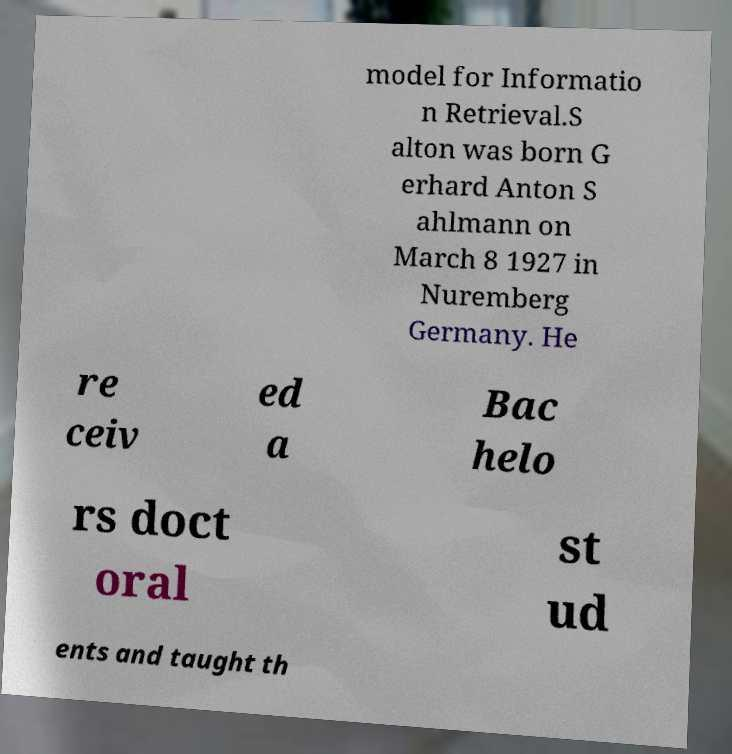There's text embedded in this image that I need extracted. Can you transcribe it verbatim? model for Informatio n Retrieval.S alton was born G erhard Anton S ahlmann on March 8 1927 in Nuremberg Germany. He re ceiv ed a Bac helo rs doct oral st ud ents and taught th 